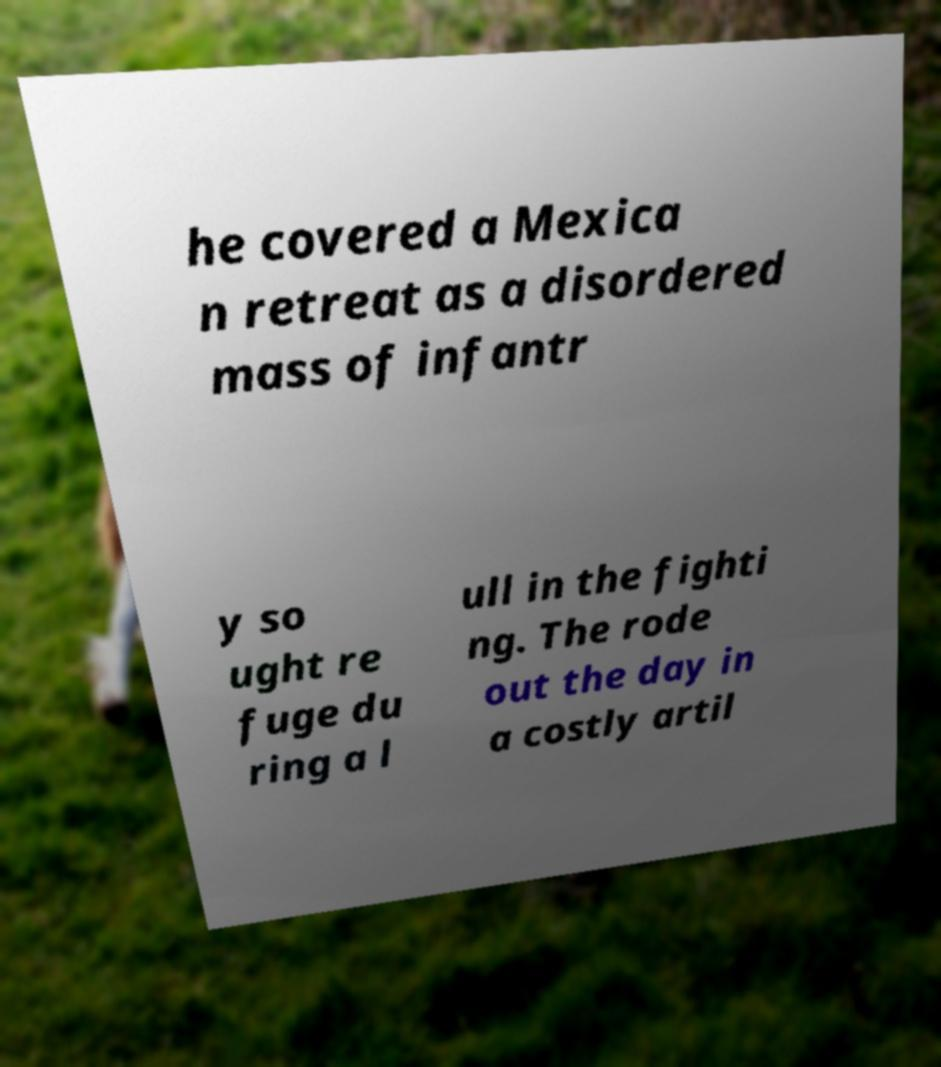I need the written content from this picture converted into text. Can you do that? he covered a Mexica n retreat as a disordered mass of infantr y so ught re fuge du ring a l ull in the fighti ng. The rode out the day in a costly artil 